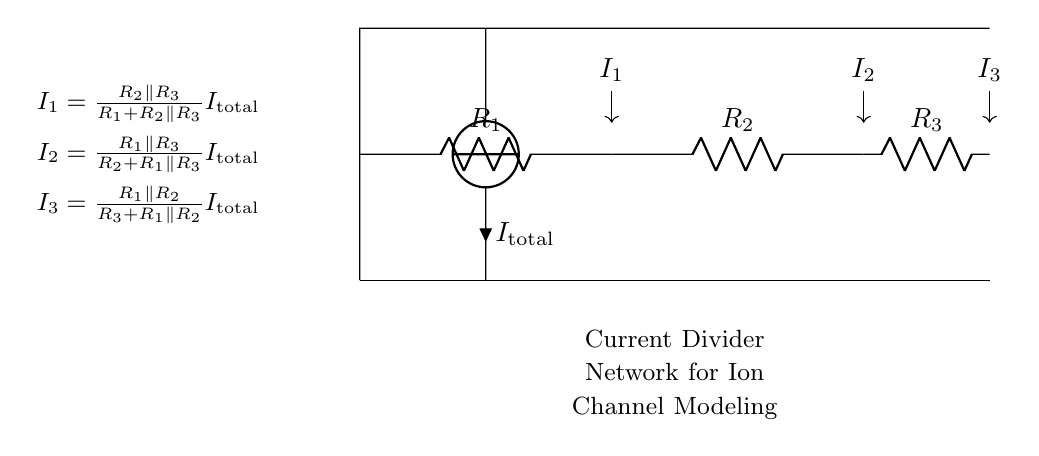What is the total current entering the current divider? The total current entering the current divider is denoted as I_total, which is the current source connected at the top of the circuit.
Answer: I_total What are the values of the resistors in the circuit? The resistors are labeled as R1, R2, and R3, but their numerical values are not provided in the diagram.
Answer: R1, R2, R3 Which resistor has the highest current flowing through it? To determine which resistor has the highest current, we look at the formulas provided. The highest current typically flows through the resistor with the lowest resistance value. Without specific resistance values, we cannot determine concretely.
Answer: Depends on resistance values What is the expression for I1? The expression for I1, as given in the diagram, is I1 = (R2 parallel R3) / (R1 + R2 parallel R3) times I_total.
Answer: (R2 parallel R3) / (R1 + R2 parallel R3) I_total How does the current divide between the resistors? The current divides according to the resistances in the circuit; each branch's current is proportional to the inverse of the resistance in that branch. This follows from the current divider rule.
Answer: Proportional to inverse of resistance What type of circuit configuration is depicted in the diagram? The circuit depicted is a current divider, which splits the input current into multiple paths based on their resistances.
Answer: Current divider 